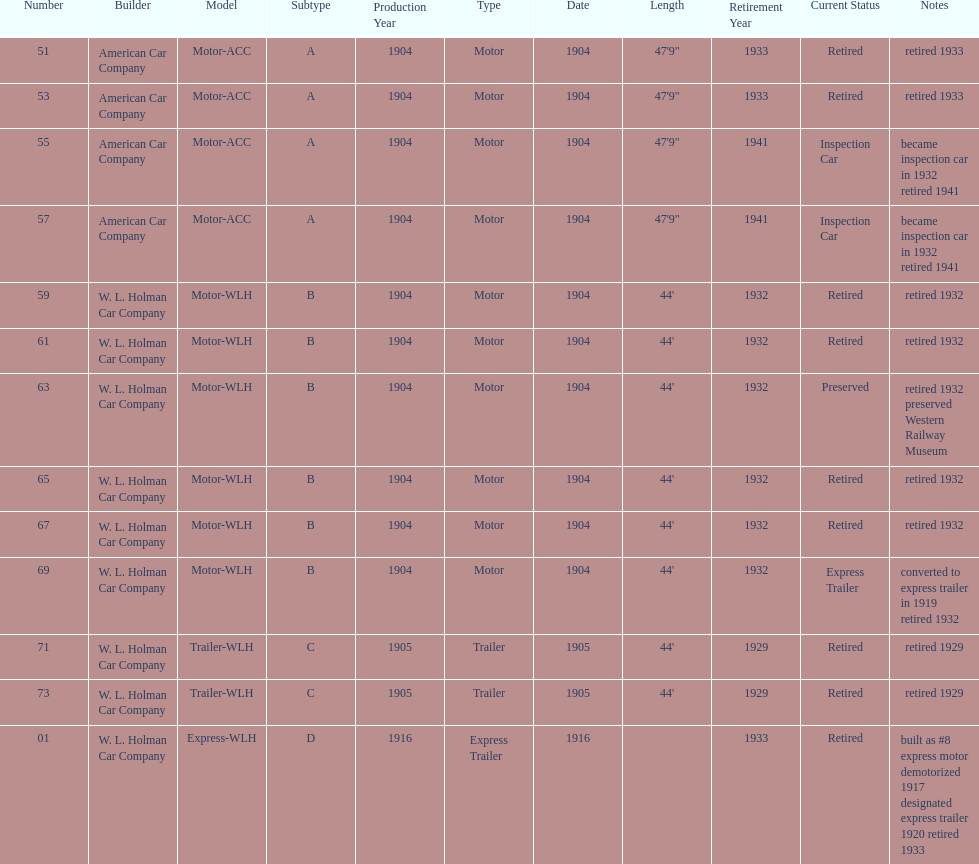How long did it take number 71 to retire? 24. 